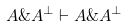<formula> <loc_0><loc_0><loc_500><loc_500>A \& A ^ { \perp } \vdash A \& A ^ { \perp }</formula> 